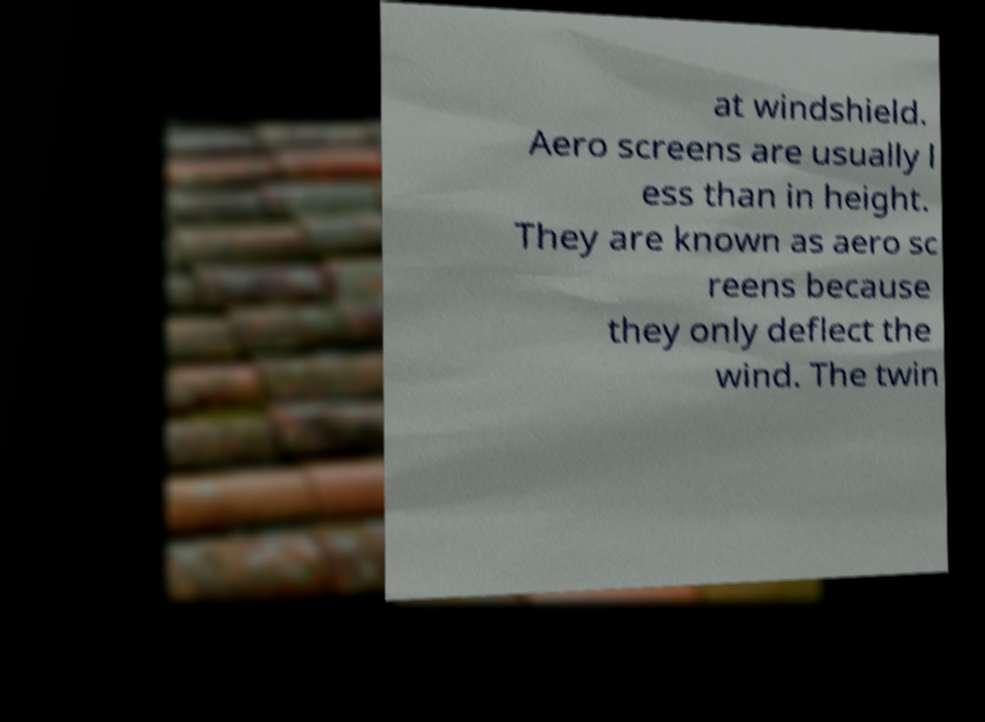For documentation purposes, I need the text within this image transcribed. Could you provide that? at windshield. Aero screens are usually l ess than in height. They are known as aero sc reens because they only deflect the wind. The twin 